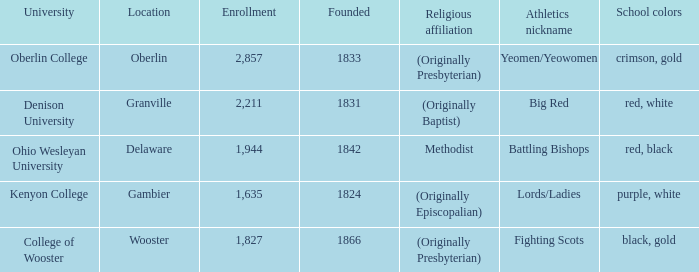What was the religious affiliation for the athletics nicknamed lords/ladies? (Originally Episcopalian). 